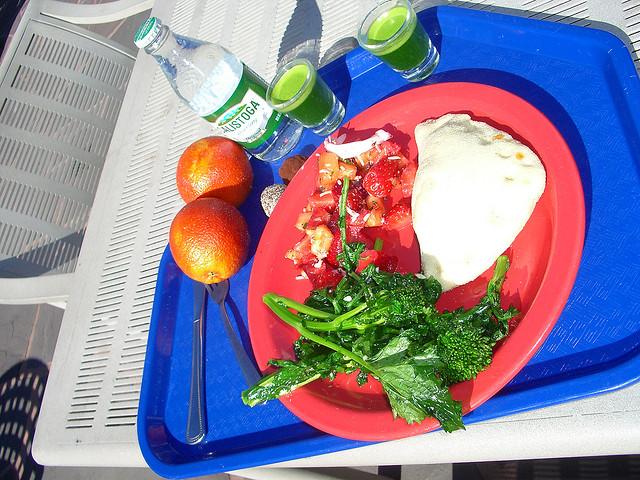What color is the plate with the broccoli?
Short answer required. Red. What type of veggie is on the plate?
Concise answer only. Broccoli. Is this something a vegetarian would eat?
Answer briefly. Yes. What type of material is the table?
Write a very short answer. Plastic. 